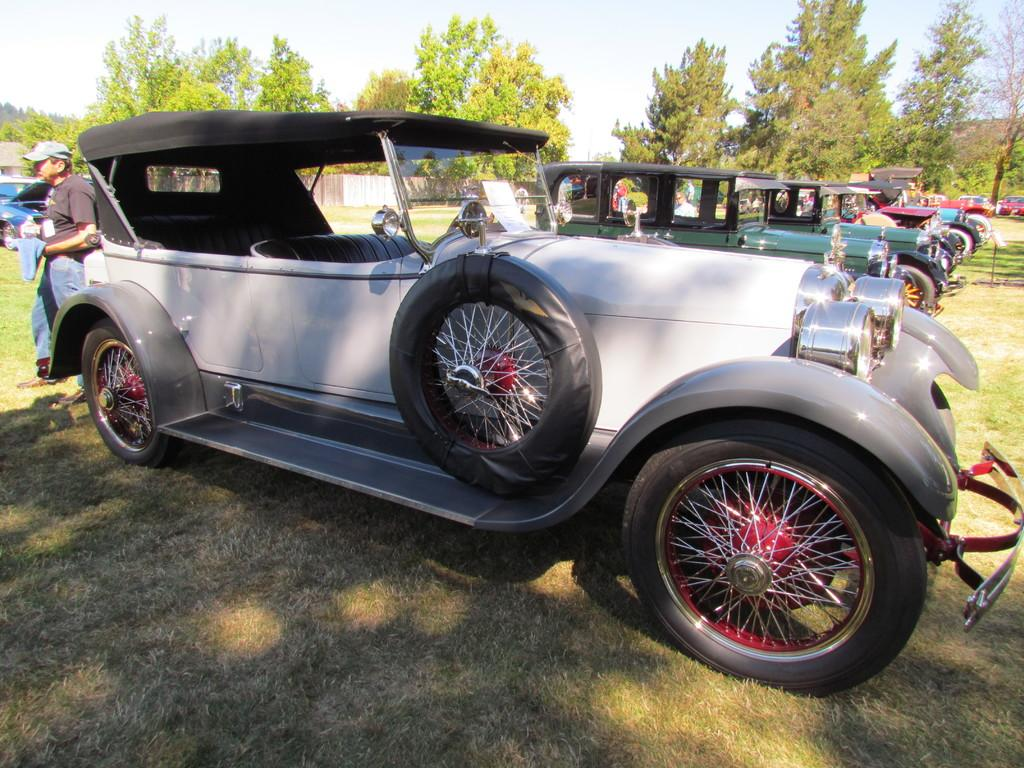What type of vehicles can be seen in the image? There are cars in the image. Where is the person located in the image? The person is standing on the left side of the image. What is the person wearing in the image? The person is wearing clothes in the image. What can be seen in the background of the image? There are trees and the sky visible in the background of the image. Can you see a nest in the trees in the background of the image? There is no nest visible in the trees in the background of the image. What type of elbow is present in the image? There is no elbow present in the image; it features cars, a person, trees, and the sky. 